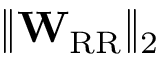Convert formula to latex. <formula><loc_0><loc_0><loc_500><loc_500>\| W _ { R R } \| _ { 2 }</formula> 